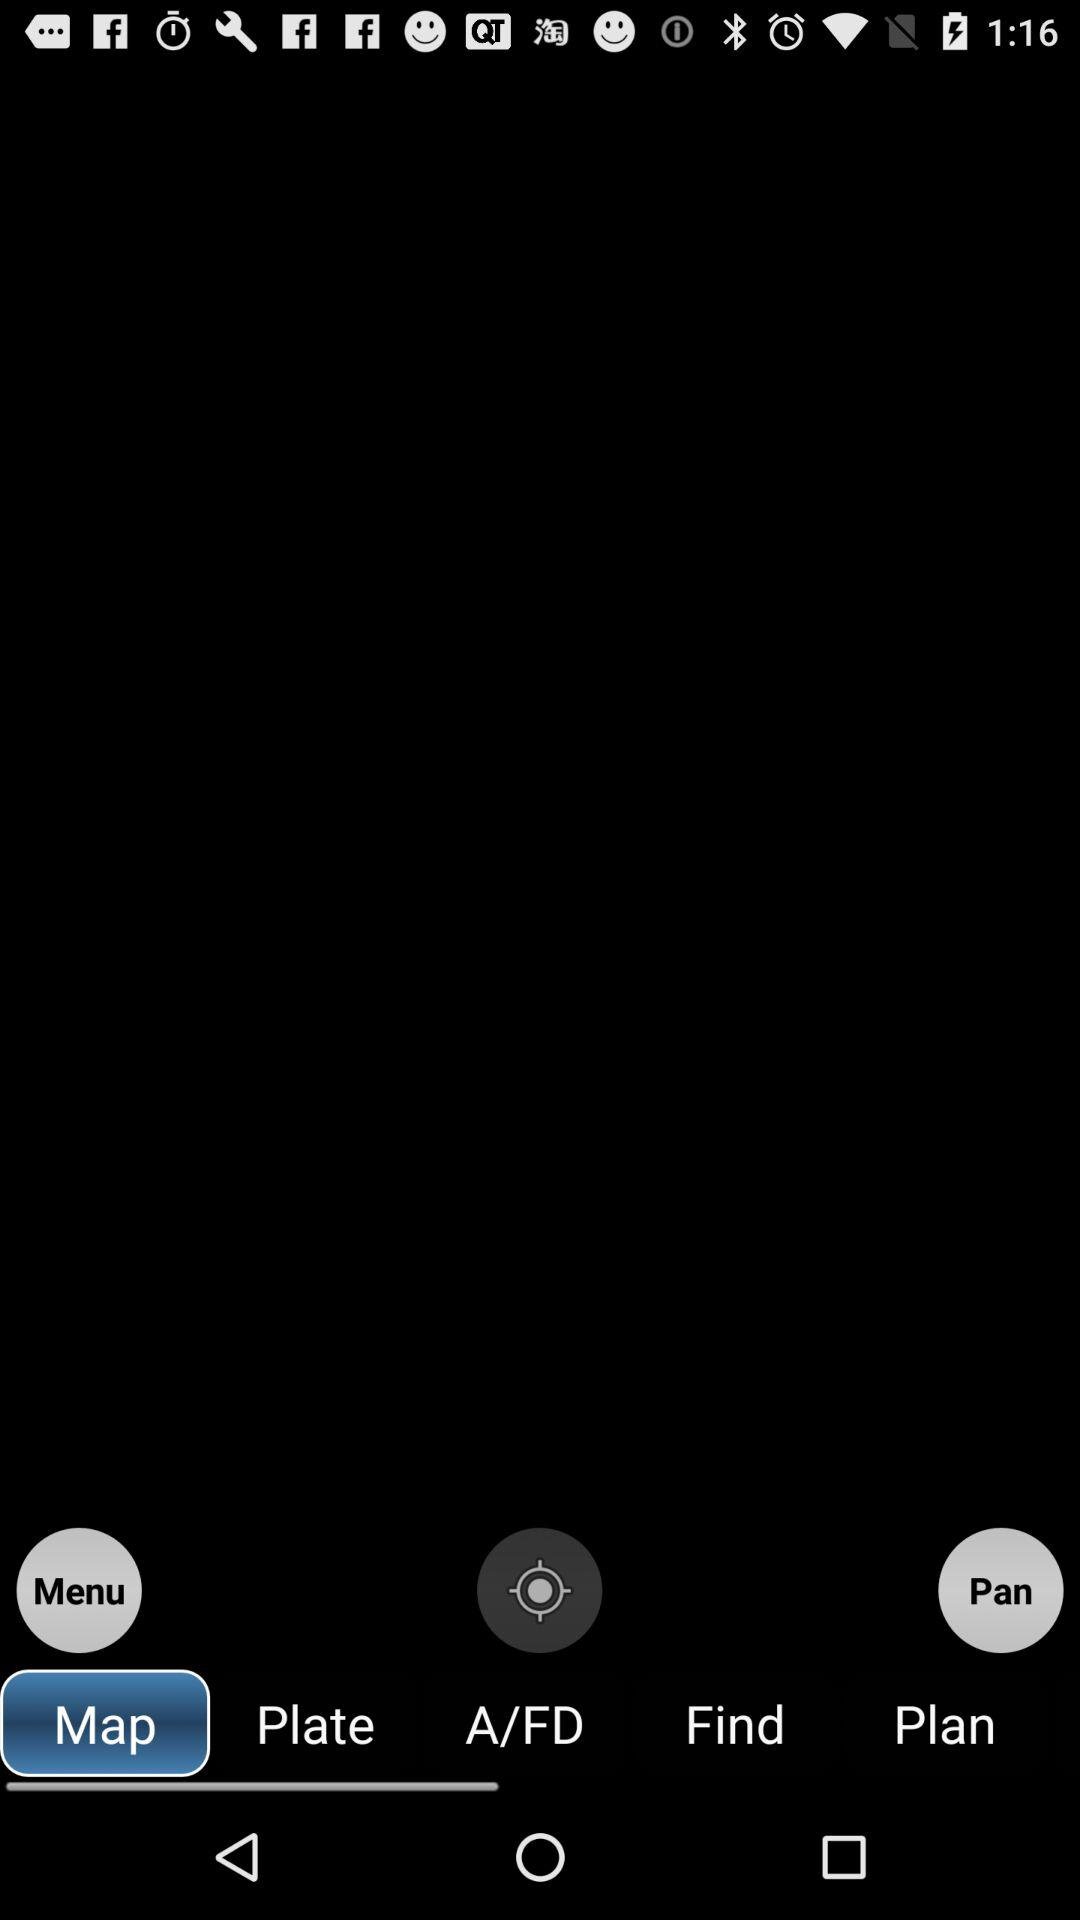Which tab is selected? The selected tab is "Map". 